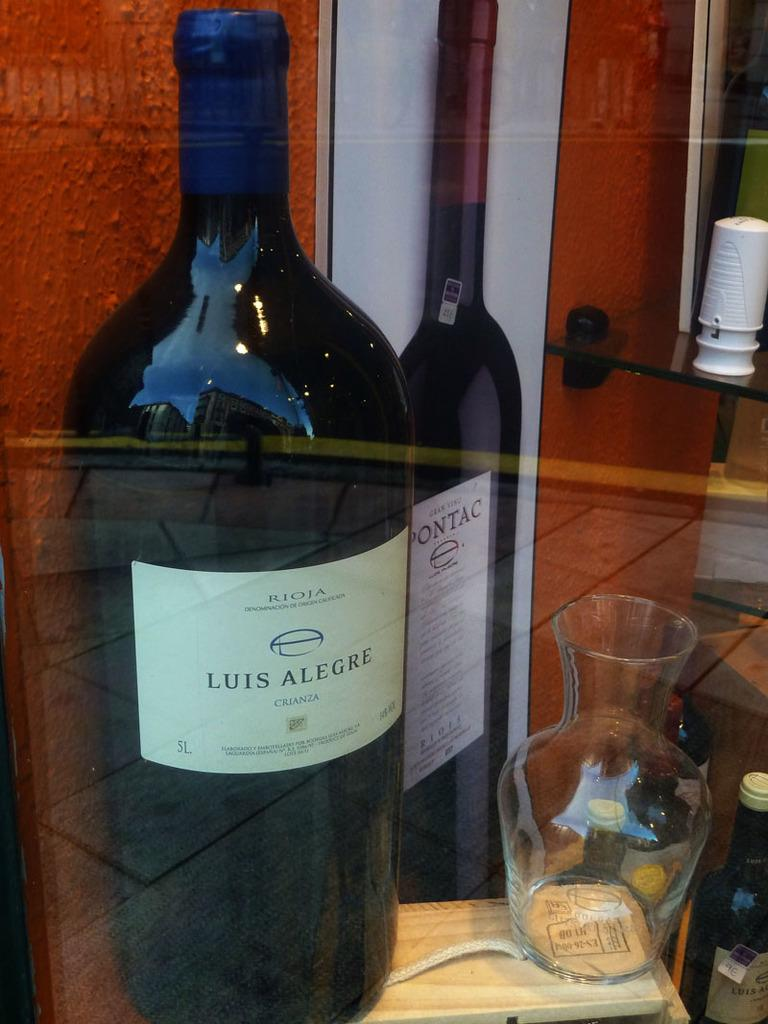<image>
Summarize the visual content of the image. Black bottle with a label that says "Luis Alegre". 